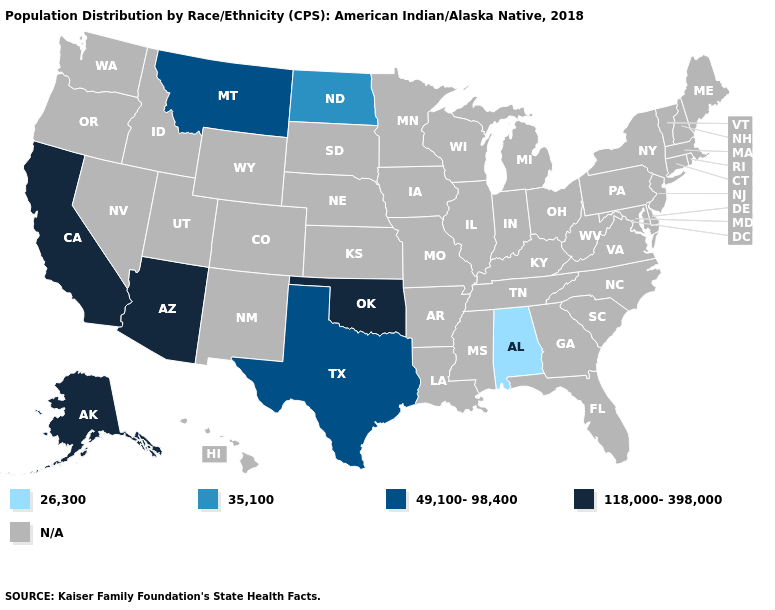What is the value of New Mexico?
Answer briefly. N/A. Which states hav the highest value in the West?
Concise answer only. Alaska, Arizona, California. Name the states that have a value in the range 49,100-98,400?
Keep it brief. Montana, Texas. Does Alabama have the lowest value in the USA?
Give a very brief answer. Yes. Name the states that have a value in the range 49,100-98,400?
Write a very short answer. Montana, Texas. Is the legend a continuous bar?
Concise answer only. No. What is the lowest value in the MidWest?
Short answer required. 35,100. Is the legend a continuous bar?
Write a very short answer. No. Name the states that have a value in the range 118,000-398,000?
Quick response, please. Alaska, Arizona, California, Oklahoma. Which states have the lowest value in the USA?
Answer briefly. Alabama. Name the states that have a value in the range 118,000-398,000?
Concise answer only. Alaska, Arizona, California, Oklahoma. 